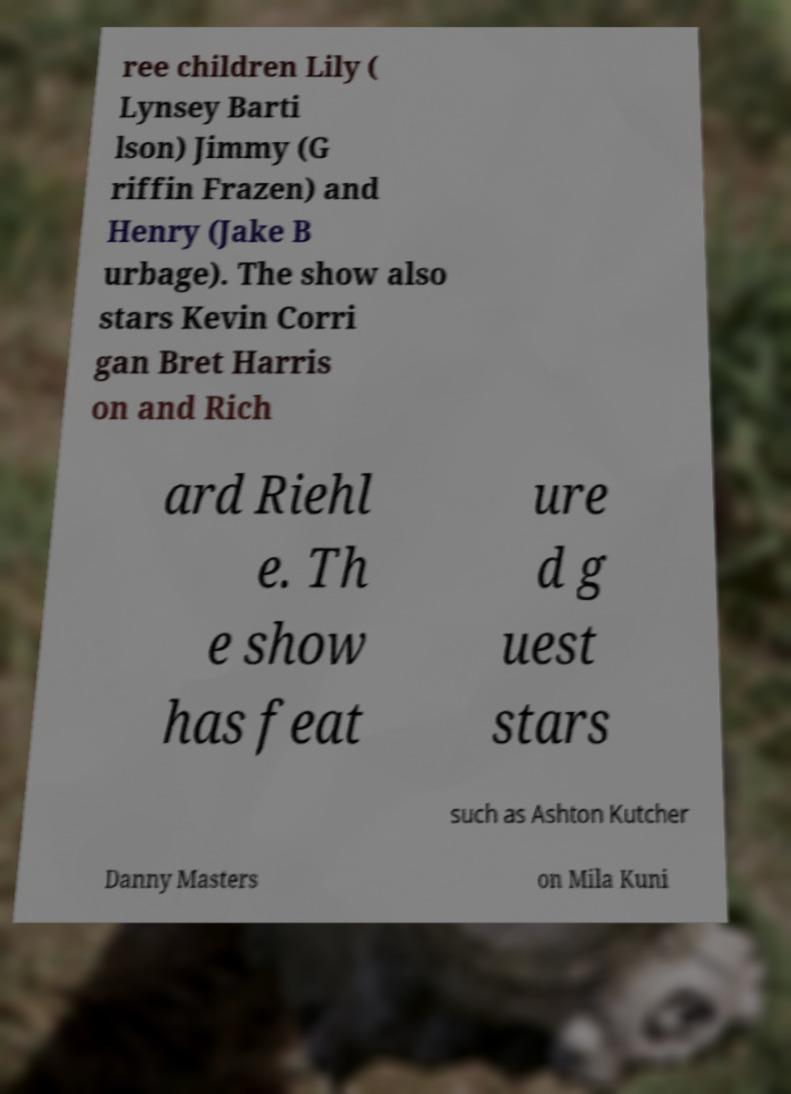Could you assist in decoding the text presented in this image and type it out clearly? ree children Lily ( Lynsey Barti lson) Jimmy (G riffin Frazen) and Henry (Jake B urbage). The show also stars Kevin Corri gan Bret Harris on and Rich ard Riehl e. Th e show has feat ure d g uest stars such as Ashton Kutcher Danny Masters on Mila Kuni 